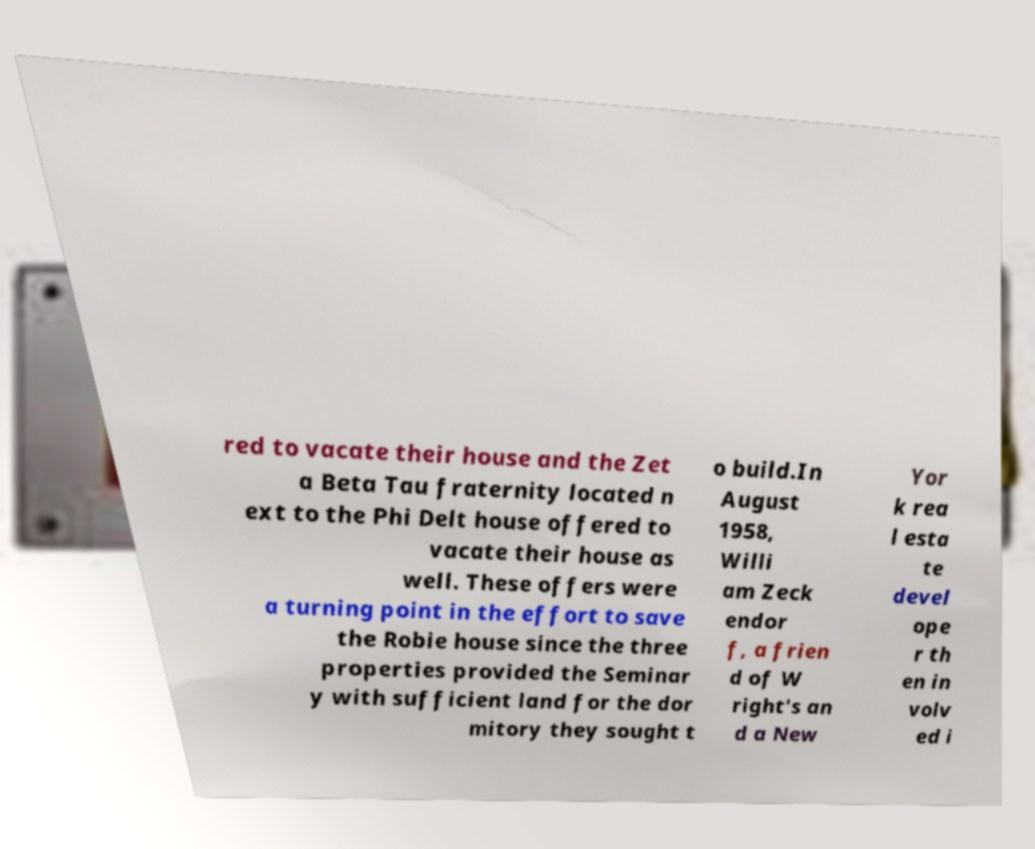Please read and relay the text visible in this image. What does it say? red to vacate their house and the Zet a Beta Tau fraternity located n ext to the Phi Delt house offered to vacate their house as well. These offers were a turning point in the effort to save the Robie house since the three properties provided the Seminar y with sufficient land for the dor mitory they sought t o build.In August 1958, Willi am Zeck endor f, a frien d of W right's an d a New Yor k rea l esta te devel ope r th en in volv ed i 